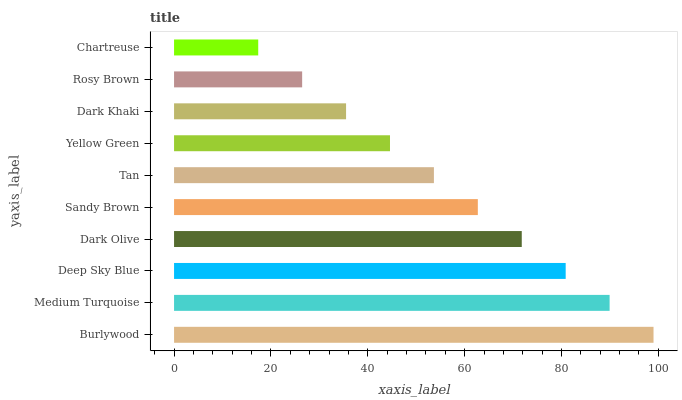Is Chartreuse the minimum?
Answer yes or no. Yes. Is Burlywood the maximum?
Answer yes or no. Yes. Is Medium Turquoise the minimum?
Answer yes or no. No. Is Medium Turquoise the maximum?
Answer yes or no. No. Is Burlywood greater than Medium Turquoise?
Answer yes or no. Yes. Is Medium Turquoise less than Burlywood?
Answer yes or no. Yes. Is Medium Turquoise greater than Burlywood?
Answer yes or no. No. Is Burlywood less than Medium Turquoise?
Answer yes or no. No. Is Sandy Brown the high median?
Answer yes or no. Yes. Is Tan the low median?
Answer yes or no. Yes. Is Chartreuse the high median?
Answer yes or no. No. Is Yellow Green the low median?
Answer yes or no. No. 